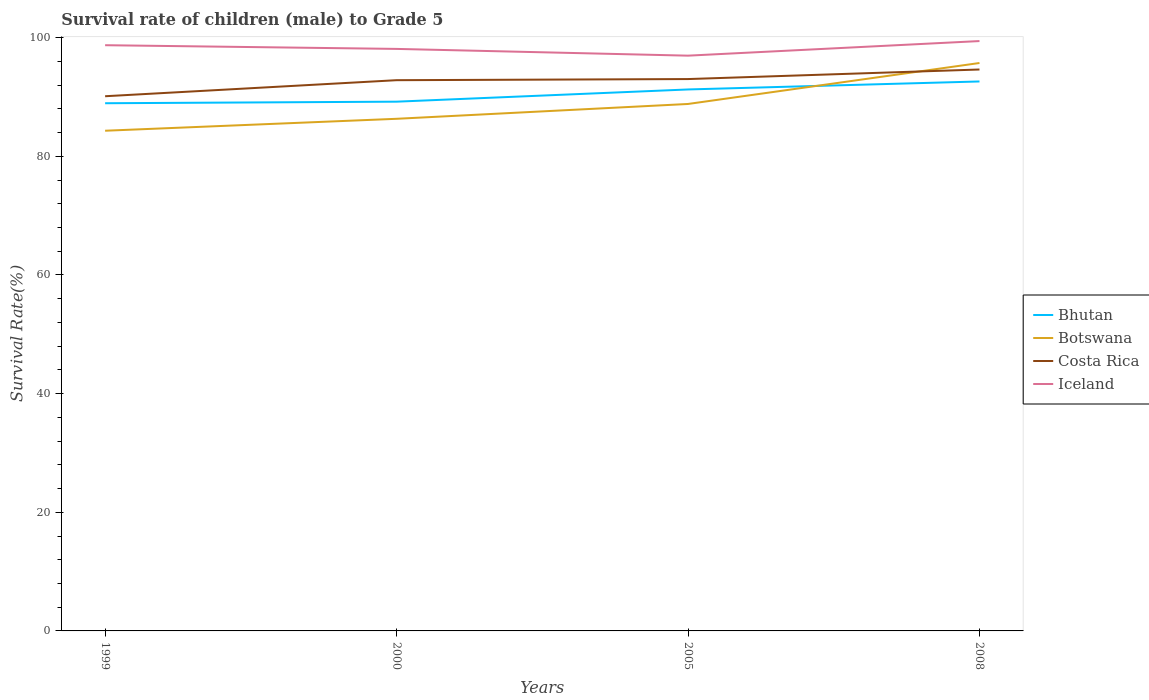How many different coloured lines are there?
Give a very brief answer. 4. Is the number of lines equal to the number of legend labels?
Your response must be concise. Yes. Across all years, what is the maximum survival rate of male children to grade 5 in Iceland?
Offer a very short reply. 96.97. What is the total survival rate of male children to grade 5 in Botswana in the graph?
Your answer should be very brief. -2.5. What is the difference between the highest and the second highest survival rate of male children to grade 5 in Bhutan?
Your answer should be very brief. 3.67. What is the difference between the highest and the lowest survival rate of male children to grade 5 in Costa Rica?
Offer a terse response. 3. Is the survival rate of male children to grade 5 in Costa Rica strictly greater than the survival rate of male children to grade 5 in Iceland over the years?
Provide a succinct answer. Yes. How many lines are there?
Your answer should be very brief. 4. How many years are there in the graph?
Your answer should be compact. 4. Does the graph contain any zero values?
Provide a short and direct response. No. Where does the legend appear in the graph?
Your response must be concise. Center right. How many legend labels are there?
Provide a succinct answer. 4. What is the title of the graph?
Keep it short and to the point. Survival rate of children (male) to Grade 5. Does "Luxembourg" appear as one of the legend labels in the graph?
Keep it short and to the point. No. What is the label or title of the X-axis?
Your answer should be compact. Years. What is the label or title of the Y-axis?
Offer a very short reply. Survival Rate(%). What is the Survival Rate(%) in Bhutan in 1999?
Make the answer very short. 88.95. What is the Survival Rate(%) in Botswana in 1999?
Provide a succinct answer. 84.31. What is the Survival Rate(%) of Costa Rica in 1999?
Provide a short and direct response. 90.13. What is the Survival Rate(%) in Iceland in 1999?
Your response must be concise. 98.73. What is the Survival Rate(%) of Bhutan in 2000?
Offer a very short reply. 89.21. What is the Survival Rate(%) of Botswana in 2000?
Offer a terse response. 86.32. What is the Survival Rate(%) of Costa Rica in 2000?
Make the answer very short. 92.83. What is the Survival Rate(%) in Iceland in 2000?
Provide a succinct answer. 98.11. What is the Survival Rate(%) in Bhutan in 2005?
Offer a terse response. 91.27. What is the Survival Rate(%) in Botswana in 2005?
Your response must be concise. 88.82. What is the Survival Rate(%) of Costa Rica in 2005?
Give a very brief answer. 93.02. What is the Survival Rate(%) in Iceland in 2005?
Provide a short and direct response. 96.97. What is the Survival Rate(%) in Bhutan in 2008?
Provide a succinct answer. 92.62. What is the Survival Rate(%) in Botswana in 2008?
Your response must be concise. 95.73. What is the Survival Rate(%) of Costa Rica in 2008?
Ensure brevity in your answer.  94.63. What is the Survival Rate(%) of Iceland in 2008?
Your answer should be very brief. 99.43. Across all years, what is the maximum Survival Rate(%) in Bhutan?
Give a very brief answer. 92.62. Across all years, what is the maximum Survival Rate(%) of Botswana?
Offer a very short reply. 95.73. Across all years, what is the maximum Survival Rate(%) of Costa Rica?
Offer a terse response. 94.63. Across all years, what is the maximum Survival Rate(%) in Iceland?
Provide a succinct answer. 99.43. Across all years, what is the minimum Survival Rate(%) in Bhutan?
Give a very brief answer. 88.95. Across all years, what is the minimum Survival Rate(%) in Botswana?
Make the answer very short. 84.31. Across all years, what is the minimum Survival Rate(%) of Costa Rica?
Provide a succinct answer. 90.13. Across all years, what is the minimum Survival Rate(%) of Iceland?
Offer a terse response. 96.97. What is the total Survival Rate(%) in Bhutan in the graph?
Make the answer very short. 362.04. What is the total Survival Rate(%) in Botswana in the graph?
Ensure brevity in your answer.  355.19. What is the total Survival Rate(%) in Costa Rica in the graph?
Ensure brevity in your answer.  370.61. What is the total Survival Rate(%) in Iceland in the graph?
Offer a terse response. 393.23. What is the difference between the Survival Rate(%) of Bhutan in 1999 and that in 2000?
Offer a very short reply. -0.26. What is the difference between the Survival Rate(%) in Botswana in 1999 and that in 2000?
Your answer should be very brief. -2.01. What is the difference between the Survival Rate(%) in Costa Rica in 1999 and that in 2000?
Provide a short and direct response. -2.7. What is the difference between the Survival Rate(%) of Iceland in 1999 and that in 2000?
Make the answer very short. 0.62. What is the difference between the Survival Rate(%) of Bhutan in 1999 and that in 2005?
Your answer should be very brief. -2.32. What is the difference between the Survival Rate(%) in Botswana in 1999 and that in 2005?
Make the answer very short. -4.51. What is the difference between the Survival Rate(%) of Costa Rica in 1999 and that in 2005?
Offer a terse response. -2.89. What is the difference between the Survival Rate(%) in Iceland in 1999 and that in 2005?
Give a very brief answer. 1.76. What is the difference between the Survival Rate(%) of Bhutan in 1999 and that in 2008?
Provide a succinct answer. -3.67. What is the difference between the Survival Rate(%) in Botswana in 1999 and that in 2008?
Your answer should be compact. -11.42. What is the difference between the Survival Rate(%) in Costa Rica in 1999 and that in 2008?
Your answer should be compact. -4.51. What is the difference between the Survival Rate(%) of Iceland in 1999 and that in 2008?
Offer a terse response. -0.7. What is the difference between the Survival Rate(%) of Bhutan in 2000 and that in 2005?
Your response must be concise. -2.06. What is the difference between the Survival Rate(%) of Botswana in 2000 and that in 2005?
Your response must be concise. -2.5. What is the difference between the Survival Rate(%) in Costa Rica in 2000 and that in 2005?
Provide a short and direct response. -0.19. What is the difference between the Survival Rate(%) of Iceland in 2000 and that in 2005?
Your answer should be very brief. 1.14. What is the difference between the Survival Rate(%) of Bhutan in 2000 and that in 2008?
Your answer should be compact. -3.41. What is the difference between the Survival Rate(%) of Botswana in 2000 and that in 2008?
Offer a terse response. -9.4. What is the difference between the Survival Rate(%) in Costa Rica in 2000 and that in 2008?
Offer a terse response. -1.8. What is the difference between the Survival Rate(%) of Iceland in 2000 and that in 2008?
Make the answer very short. -1.32. What is the difference between the Survival Rate(%) in Bhutan in 2005 and that in 2008?
Give a very brief answer. -1.35. What is the difference between the Survival Rate(%) of Botswana in 2005 and that in 2008?
Your response must be concise. -6.91. What is the difference between the Survival Rate(%) of Costa Rica in 2005 and that in 2008?
Your answer should be very brief. -1.61. What is the difference between the Survival Rate(%) of Iceland in 2005 and that in 2008?
Provide a short and direct response. -2.46. What is the difference between the Survival Rate(%) of Bhutan in 1999 and the Survival Rate(%) of Botswana in 2000?
Provide a succinct answer. 2.62. What is the difference between the Survival Rate(%) of Bhutan in 1999 and the Survival Rate(%) of Costa Rica in 2000?
Provide a succinct answer. -3.88. What is the difference between the Survival Rate(%) in Bhutan in 1999 and the Survival Rate(%) in Iceland in 2000?
Make the answer very short. -9.16. What is the difference between the Survival Rate(%) in Botswana in 1999 and the Survival Rate(%) in Costa Rica in 2000?
Your answer should be very brief. -8.52. What is the difference between the Survival Rate(%) of Botswana in 1999 and the Survival Rate(%) of Iceland in 2000?
Your answer should be compact. -13.79. What is the difference between the Survival Rate(%) of Costa Rica in 1999 and the Survival Rate(%) of Iceland in 2000?
Your answer should be compact. -7.98. What is the difference between the Survival Rate(%) in Bhutan in 1999 and the Survival Rate(%) in Botswana in 2005?
Offer a terse response. 0.12. What is the difference between the Survival Rate(%) in Bhutan in 1999 and the Survival Rate(%) in Costa Rica in 2005?
Provide a short and direct response. -4.07. What is the difference between the Survival Rate(%) of Bhutan in 1999 and the Survival Rate(%) of Iceland in 2005?
Make the answer very short. -8.02. What is the difference between the Survival Rate(%) in Botswana in 1999 and the Survival Rate(%) in Costa Rica in 2005?
Offer a very short reply. -8.71. What is the difference between the Survival Rate(%) in Botswana in 1999 and the Survival Rate(%) in Iceland in 2005?
Make the answer very short. -12.66. What is the difference between the Survival Rate(%) in Costa Rica in 1999 and the Survival Rate(%) in Iceland in 2005?
Your answer should be compact. -6.84. What is the difference between the Survival Rate(%) of Bhutan in 1999 and the Survival Rate(%) of Botswana in 2008?
Provide a succinct answer. -6.78. What is the difference between the Survival Rate(%) in Bhutan in 1999 and the Survival Rate(%) in Costa Rica in 2008?
Your answer should be very brief. -5.69. What is the difference between the Survival Rate(%) of Bhutan in 1999 and the Survival Rate(%) of Iceland in 2008?
Give a very brief answer. -10.48. What is the difference between the Survival Rate(%) of Botswana in 1999 and the Survival Rate(%) of Costa Rica in 2008?
Provide a succinct answer. -10.32. What is the difference between the Survival Rate(%) in Botswana in 1999 and the Survival Rate(%) in Iceland in 2008?
Provide a succinct answer. -15.12. What is the difference between the Survival Rate(%) of Costa Rica in 1999 and the Survival Rate(%) of Iceland in 2008?
Your response must be concise. -9.3. What is the difference between the Survival Rate(%) in Bhutan in 2000 and the Survival Rate(%) in Botswana in 2005?
Give a very brief answer. 0.39. What is the difference between the Survival Rate(%) in Bhutan in 2000 and the Survival Rate(%) in Costa Rica in 2005?
Your answer should be compact. -3.81. What is the difference between the Survival Rate(%) of Bhutan in 2000 and the Survival Rate(%) of Iceland in 2005?
Your answer should be compact. -7.76. What is the difference between the Survival Rate(%) of Botswana in 2000 and the Survival Rate(%) of Costa Rica in 2005?
Offer a very short reply. -6.7. What is the difference between the Survival Rate(%) of Botswana in 2000 and the Survival Rate(%) of Iceland in 2005?
Your response must be concise. -10.64. What is the difference between the Survival Rate(%) of Costa Rica in 2000 and the Survival Rate(%) of Iceland in 2005?
Offer a very short reply. -4.14. What is the difference between the Survival Rate(%) in Bhutan in 2000 and the Survival Rate(%) in Botswana in 2008?
Your answer should be very brief. -6.52. What is the difference between the Survival Rate(%) of Bhutan in 2000 and the Survival Rate(%) of Costa Rica in 2008?
Provide a succinct answer. -5.42. What is the difference between the Survival Rate(%) of Bhutan in 2000 and the Survival Rate(%) of Iceland in 2008?
Your answer should be compact. -10.22. What is the difference between the Survival Rate(%) in Botswana in 2000 and the Survival Rate(%) in Costa Rica in 2008?
Give a very brief answer. -8.31. What is the difference between the Survival Rate(%) in Botswana in 2000 and the Survival Rate(%) in Iceland in 2008?
Offer a terse response. -13.1. What is the difference between the Survival Rate(%) in Costa Rica in 2000 and the Survival Rate(%) in Iceland in 2008?
Offer a terse response. -6.6. What is the difference between the Survival Rate(%) of Bhutan in 2005 and the Survival Rate(%) of Botswana in 2008?
Provide a short and direct response. -4.46. What is the difference between the Survival Rate(%) of Bhutan in 2005 and the Survival Rate(%) of Costa Rica in 2008?
Provide a short and direct response. -3.37. What is the difference between the Survival Rate(%) in Bhutan in 2005 and the Survival Rate(%) in Iceland in 2008?
Your response must be concise. -8.16. What is the difference between the Survival Rate(%) of Botswana in 2005 and the Survival Rate(%) of Costa Rica in 2008?
Make the answer very short. -5.81. What is the difference between the Survival Rate(%) in Botswana in 2005 and the Survival Rate(%) in Iceland in 2008?
Make the answer very short. -10.6. What is the difference between the Survival Rate(%) in Costa Rica in 2005 and the Survival Rate(%) in Iceland in 2008?
Offer a terse response. -6.41. What is the average Survival Rate(%) of Bhutan per year?
Provide a short and direct response. 90.51. What is the average Survival Rate(%) in Botswana per year?
Ensure brevity in your answer.  88.8. What is the average Survival Rate(%) in Costa Rica per year?
Give a very brief answer. 92.65. What is the average Survival Rate(%) in Iceland per year?
Give a very brief answer. 98.31. In the year 1999, what is the difference between the Survival Rate(%) of Bhutan and Survival Rate(%) of Botswana?
Give a very brief answer. 4.64. In the year 1999, what is the difference between the Survival Rate(%) of Bhutan and Survival Rate(%) of Costa Rica?
Your answer should be compact. -1.18. In the year 1999, what is the difference between the Survival Rate(%) in Bhutan and Survival Rate(%) in Iceland?
Make the answer very short. -9.78. In the year 1999, what is the difference between the Survival Rate(%) of Botswana and Survival Rate(%) of Costa Rica?
Ensure brevity in your answer.  -5.82. In the year 1999, what is the difference between the Survival Rate(%) of Botswana and Survival Rate(%) of Iceland?
Make the answer very short. -14.42. In the year 1999, what is the difference between the Survival Rate(%) of Costa Rica and Survival Rate(%) of Iceland?
Offer a very short reply. -8.6. In the year 2000, what is the difference between the Survival Rate(%) in Bhutan and Survival Rate(%) in Botswana?
Ensure brevity in your answer.  2.89. In the year 2000, what is the difference between the Survival Rate(%) in Bhutan and Survival Rate(%) in Costa Rica?
Offer a very short reply. -3.62. In the year 2000, what is the difference between the Survival Rate(%) in Bhutan and Survival Rate(%) in Iceland?
Make the answer very short. -8.9. In the year 2000, what is the difference between the Survival Rate(%) in Botswana and Survival Rate(%) in Costa Rica?
Give a very brief answer. -6.51. In the year 2000, what is the difference between the Survival Rate(%) in Botswana and Survival Rate(%) in Iceland?
Ensure brevity in your answer.  -11.78. In the year 2000, what is the difference between the Survival Rate(%) in Costa Rica and Survival Rate(%) in Iceland?
Offer a terse response. -5.27. In the year 2005, what is the difference between the Survival Rate(%) in Bhutan and Survival Rate(%) in Botswana?
Ensure brevity in your answer.  2.45. In the year 2005, what is the difference between the Survival Rate(%) in Bhutan and Survival Rate(%) in Costa Rica?
Ensure brevity in your answer.  -1.75. In the year 2005, what is the difference between the Survival Rate(%) in Bhutan and Survival Rate(%) in Iceland?
Your answer should be compact. -5.7. In the year 2005, what is the difference between the Survival Rate(%) in Botswana and Survival Rate(%) in Costa Rica?
Keep it short and to the point. -4.2. In the year 2005, what is the difference between the Survival Rate(%) in Botswana and Survival Rate(%) in Iceland?
Make the answer very short. -8.14. In the year 2005, what is the difference between the Survival Rate(%) in Costa Rica and Survival Rate(%) in Iceland?
Offer a very short reply. -3.95. In the year 2008, what is the difference between the Survival Rate(%) of Bhutan and Survival Rate(%) of Botswana?
Your answer should be very brief. -3.11. In the year 2008, what is the difference between the Survival Rate(%) in Bhutan and Survival Rate(%) in Costa Rica?
Give a very brief answer. -2.02. In the year 2008, what is the difference between the Survival Rate(%) of Bhutan and Survival Rate(%) of Iceland?
Ensure brevity in your answer.  -6.81. In the year 2008, what is the difference between the Survival Rate(%) of Botswana and Survival Rate(%) of Costa Rica?
Keep it short and to the point. 1.09. In the year 2008, what is the difference between the Survival Rate(%) of Botswana and Survival Rate(%) of Iceland?
Your answer should be very brief. -3.7. In the year 2008, what is the difference between the Survival Rate(%) in Costa Rica and Survival Rate(%) in Iceland?
Make the answer very short. -4.79. What is the ratio of the Survival Rate(%) of Botswana in 1999 to that in 2000?
Offer a terse response. 0.98. What is the ratio of the Survival Rate(%) of Costa Rica in 1999 to that in 2000?
Offer a terse response. 0.97. What is the ratio of the Survival Rate(%) of Iceland in 1999 to that in 2000?
Keep it short and to the point. 1.01. What is the ratio of the Survival Rate(%) in Bhutan in 1999 to that in 2005?
Your answer should be very brief. 0.97. What is the ratio of the Survival Rate(%) of Botswana in 1999 to that in 2005?
Offer a very short reply. 0.95. What is the ratio of the Survival Rate(%) in Costa Rica in 1999 to that in 2005?
Provide a short and direct response. 0.97. What is the ratio of the Survival Rate(%) of Iceland in 1999 to that in 2005?
Offer a very short reply. 1.02. What is the ratio of the Survival Rate(%) of Bhutan in 1999 to that in 2008?
Your response must be concise. 0.96. What is the ratio of the Survival Rate(%) of Botswana in 1999 to that in 2008?
Your answer should be compact. 0.88. What is the ratio of the Survival Rate(%) in Costa Rica in 1999 to that in 2008?
Offer a terse response. 0.95. What is the ratio of the Survival Rate(%) of Iceland in 1999 to that in 2008?
Offer a very short reply. 0.99. What is the ratio of the Survival Rate(%) in Bhutan in 2000 to that in 2005?
Provide a succinct answer. 0.98. What is the ratio of the Survival Rate(%) of Botswana in 2000 to that in 2005?
Offer a terse response. 0.97. What is the ratio of the Survival Rate(%) of Costa Rica in 2000 to that in 2005?
Your answer should be very brief. 1. What is the ratio of the Survival Rate(%) in Iceland in 2000 to that in 2005?
Keep it short and to the point. 1.01. What is the ratio of the Survival Rate(%) in Bhutan in 2000 to that in 2008?
Provide a succinct answer. 0.96. What is the ratio of the Survival Rate(%) of Botswana in 2000 to that in 2008?
Your answer should be compact. 0.9. What is the ratio of the Survival Rate(%) of Costa Rica in 2000 to that in 2008?
Give a very brief answer. 0.98. What is the ratio of the Survival Rate(%) in Iceland in 2000 to that in 2008?
Offer a very short reply. 0.99. What is the ratio of the Survival Rate(%) in Bhutan in 2005 to that in 2008?
Make the answer very short. 0.99. What is the ratio of the Survival Rate(%) in Botswana in 2005 to that in 2008?
Provide a short and direct response. 0.93. What is the ratio of the Survival Rate(%) of Iceland in 2005 to that in 2008?
Offer a very short reply. 0.98. What is the difference between the highest and the second highest Survival Rate(%) of Bhutan?
Provide a succinct answer. 1.35. What is the difference between the highest and the second highest Survival Rate(%) of Botswana?
Give a very brief answer. 6.91. What is the difference between the highest and the second highest Survival Rate(%) in Costa Rica?
Give a very brief answer. 1.61. What is the difference between the highest and the second highest Survival Rate(%) of Iceland?
Offer a terse response. 0.7. What is the difference between the highest and the lowest Survival Rate(%) of Bhutan?
Keep it short and to the point. 3.67. What is the difference between the highest and the lowest Survival Rate(%) in Botswana?
Offer a very short reply. 11.42. What is the difference between the highest and the lowest Survival Rate(%) of Costa Rica?
Keep it short and to the point. 4.51. What is the difference between the highest and the lowest Survival Rate(%) of Iceland?
Keep it short and to the point. 2.46. 